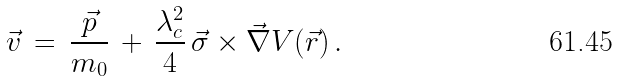<formula> <loc_0><loc_0><loc_500><loc_500>\vec { v } \, = \, \frac { \vec { p } } { m _ { 0 } } \, + \, \frac { \lambda _ { c } ^ { 2 } } { 4 } \, \vec { \sigma } \times \vec { \nabla } V ( \vec { r } ) \, .</formula> 